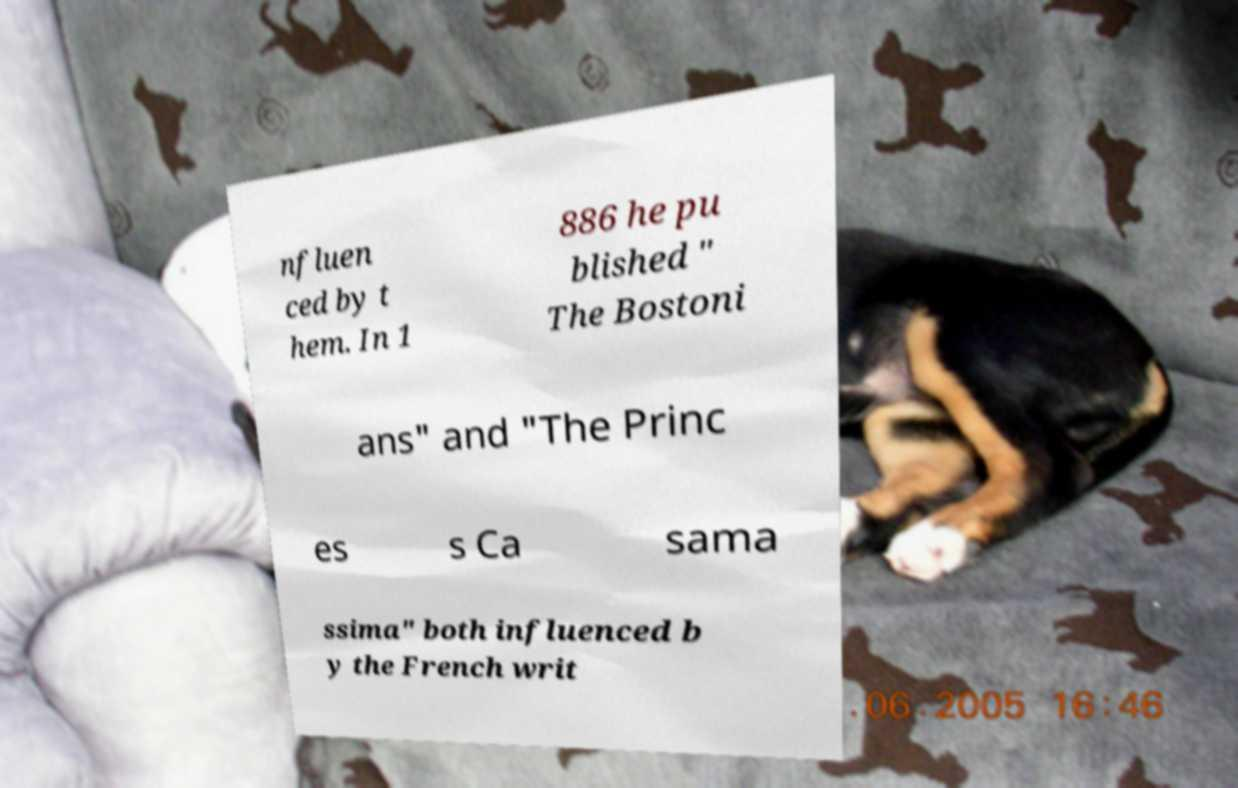Could you assist in decoding the text presented in this image and type it out clearly? nfluen ced by t hem. In 1 886 he pu blished " The Bostoni ans" and "The Princ es s Ca sama ssima" both influenced b y the French writ 